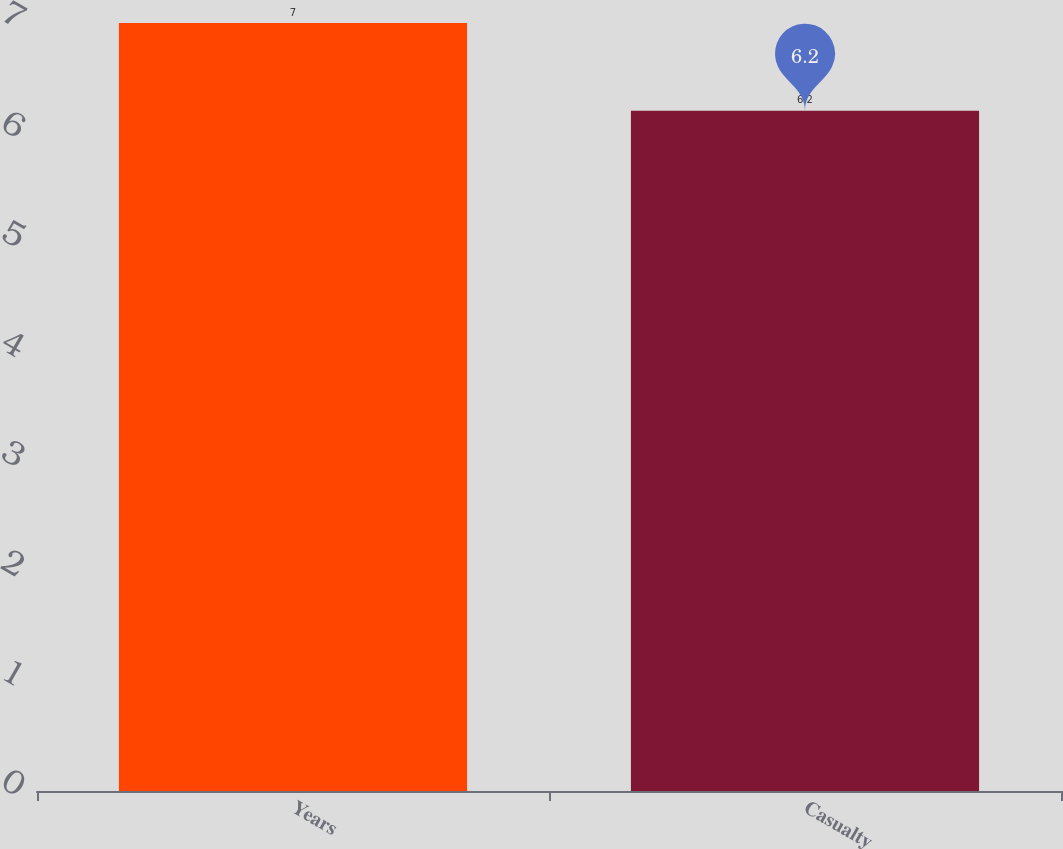Convert chart. <chart><loc_0><loc_0><loc_500><loc_500><bar_chart><fcel>Years<fcel>Casualty<nl><fcel>7<fcel>6.2<nl></chart> 